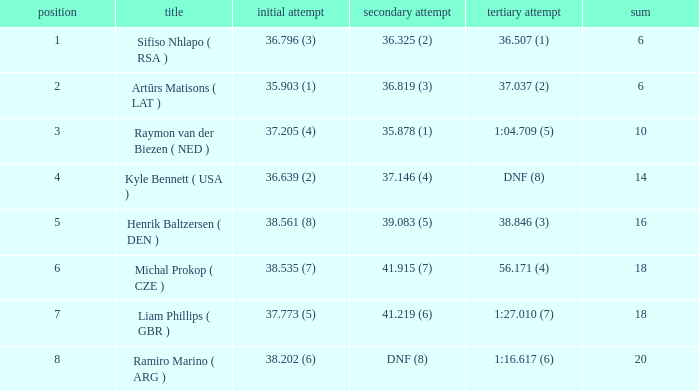Which 3rd run has rank of 1? 36.507 (1). 